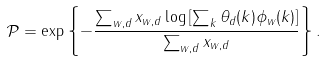Convert formula to latex. <formula><loc_0><loc_0><loc_500><loc_500>\mathcal { P } = \exp \left \{ - \frac { \sum _ { w , d } x _ { w , d } \log \left [ \sum _ { k } \theta _ { d } ( k ) \phi _ { w } ( k ) \right ] } { \sum _ { w , d } x _ { w , d } } \right \} .</formula> 